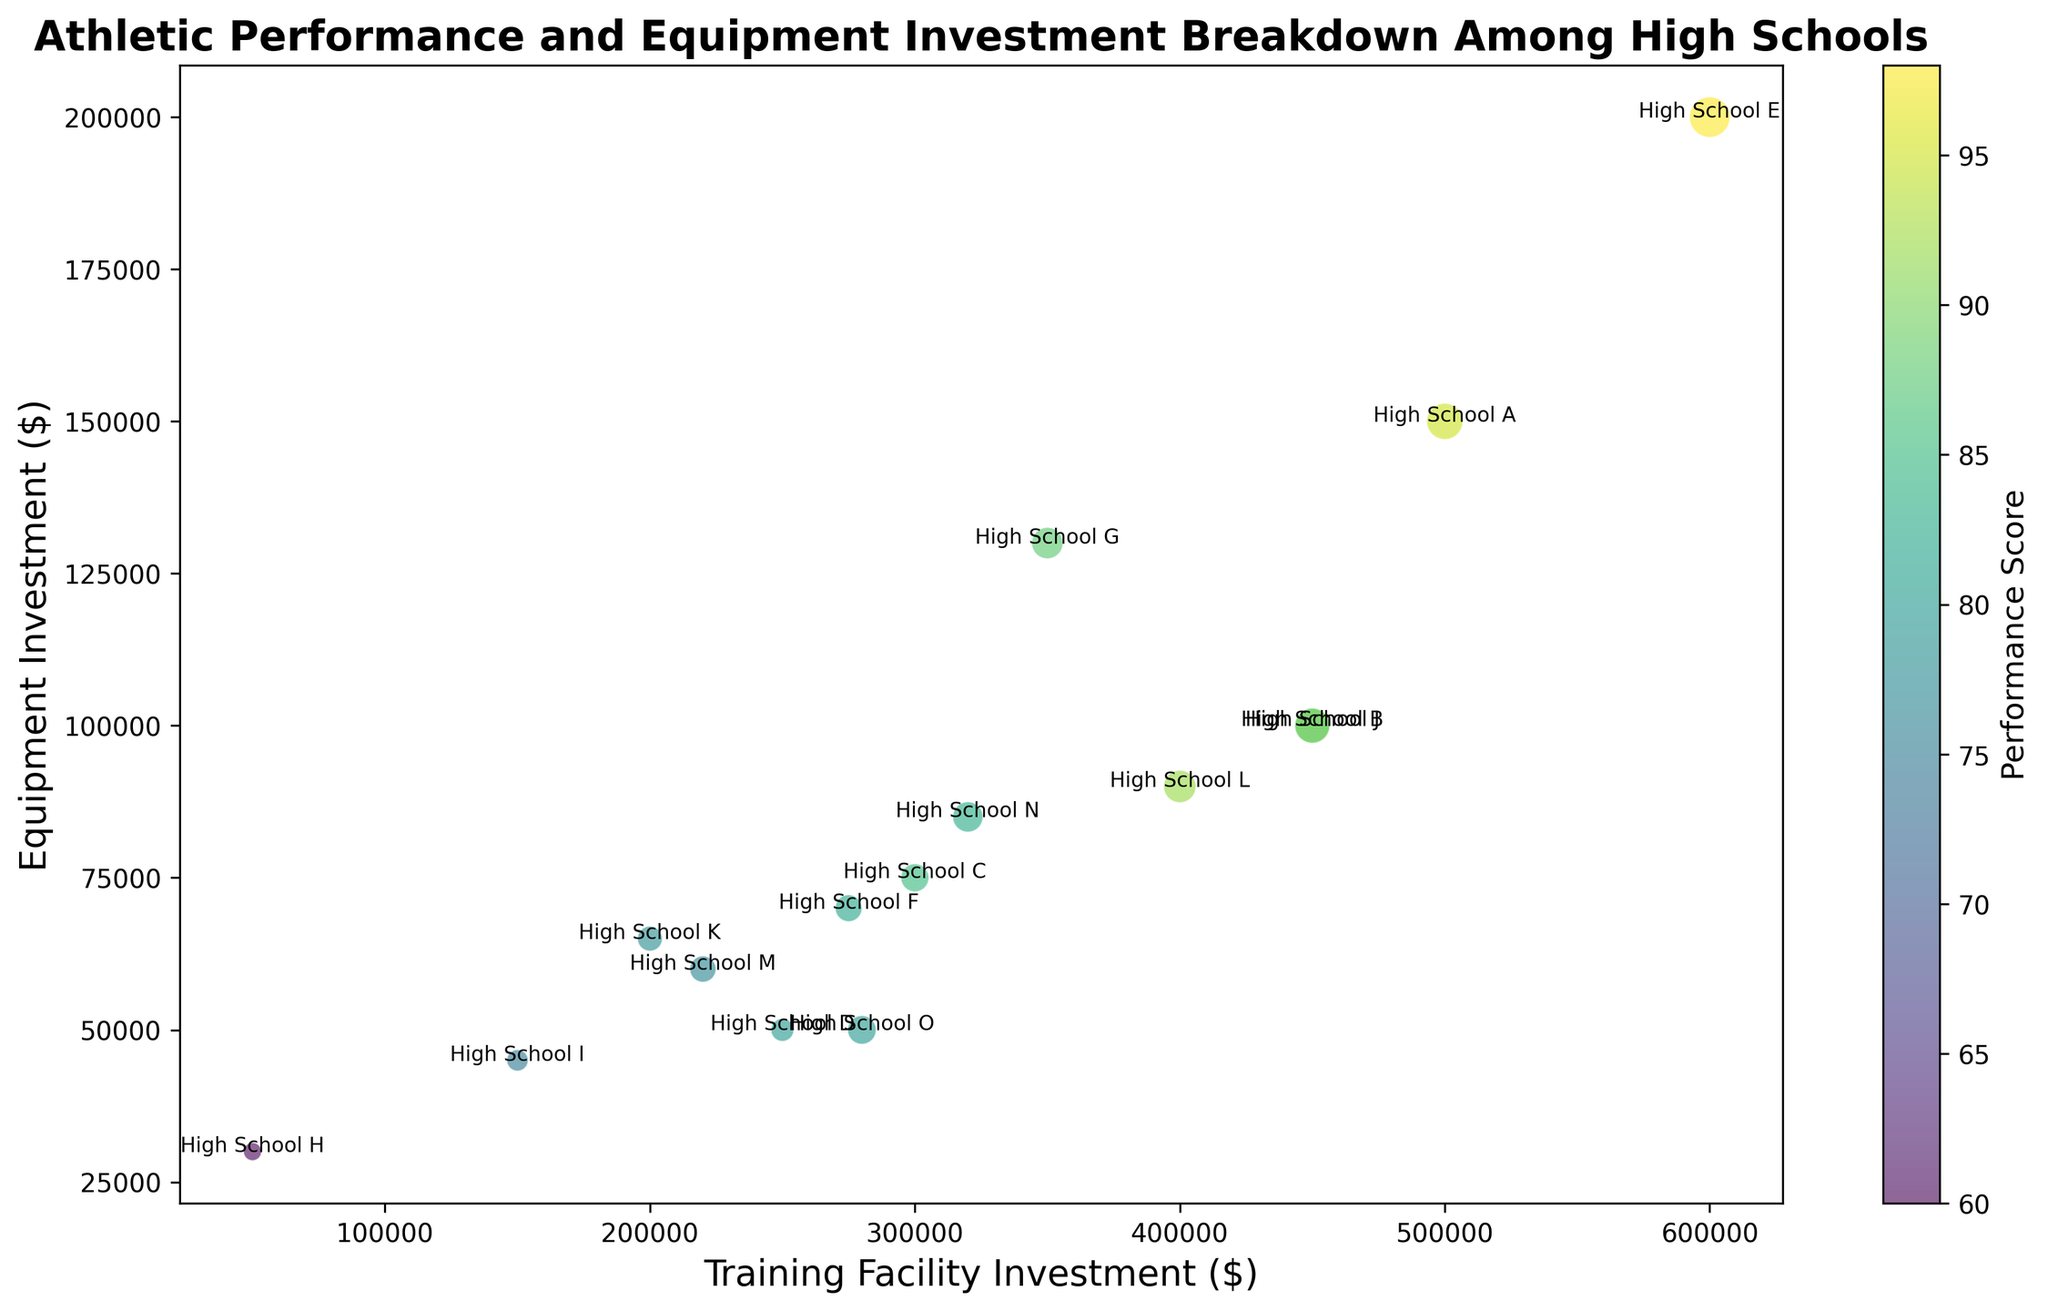Which high school has the highest performance score? To determine which high school has the highest performance score, look at the color bar that indicates performance scores. Find the bubble with the darkest shade corresponding to the highest score.
Answer: High School E Which high school has the lowest equipment investment? Compare all the bubbles and identify the one positioned furthest to the left on the x-axis, representing the lowest equipment investment.
Answer: High School H What's the average training facility investment among the high schools with a performance score greater than 90? Identify the high schools with performance scores greater than 90: A, E, and L. Sum their training facility investments (500000 + 600000 + 400000) and divide by the number of high schools (3). So, 1500000 / 3
Answer: 500000 Which high school has a higher performance score, School G or School J? Locate both School G and School J on the plot and compare their corresponding color shades. According to the color bar, verify which shade indicates a higher performance score.
Answer: School J Which high school has the largest bubble in the chart? The size of the bubble corresponds to the annual scholarship fund. Identify the largest bubble visually.
Answer: High School E Which high schools have performance scores equal to or greater than 90 but less than 95? Identify the bubbles with a color corresponding to performance scores between 90 and 94, inclusive, by referring to the color bar. Schools fitting this criterion are B, J, and L.
Answer: High School B, High School J, High School L Among High School C, D, and G, which one has the highest equipment investment? Locate High School C, D, and G and compare their positions on the y-axis to see which one is highest.
Answer: High School G What is the total annual scholarship fund for schools with a training facility investment of at least 450,000? Identify schools with training facility investments of 450,000 or more: A, B, E, and J. Add their scholarship funds (200000 + 180000 + 250000 + 190000). So, 820000.
Answer: 820000 What is the difference in equipment investment between the highest and lowest performing schools? Identify the highest (E, 600000) and lowest (H, 50000) performing schools and subtract their equipment investments from one another. So, 200000 - 30000 = 170000.
Answer: 170000 Which high school has a training facility investment closest to the median of all the high schools? To find the median of the training facility investments, first list them in order: 50000, 150000, 200000, 220000, 250000, 275000, 280000, 300000, 320000, 350000, 400000, 450000, 450000, 500000, 600000. The median value for 15 numbers is the 8th value, which is 300000. Identify the high school with this investment amount, which is High School C.
Answer: High School C 